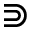Convert formula to latex. <formula><loc_0><loc_0><loc_500><loc_500>\S u p s e t</formula> 